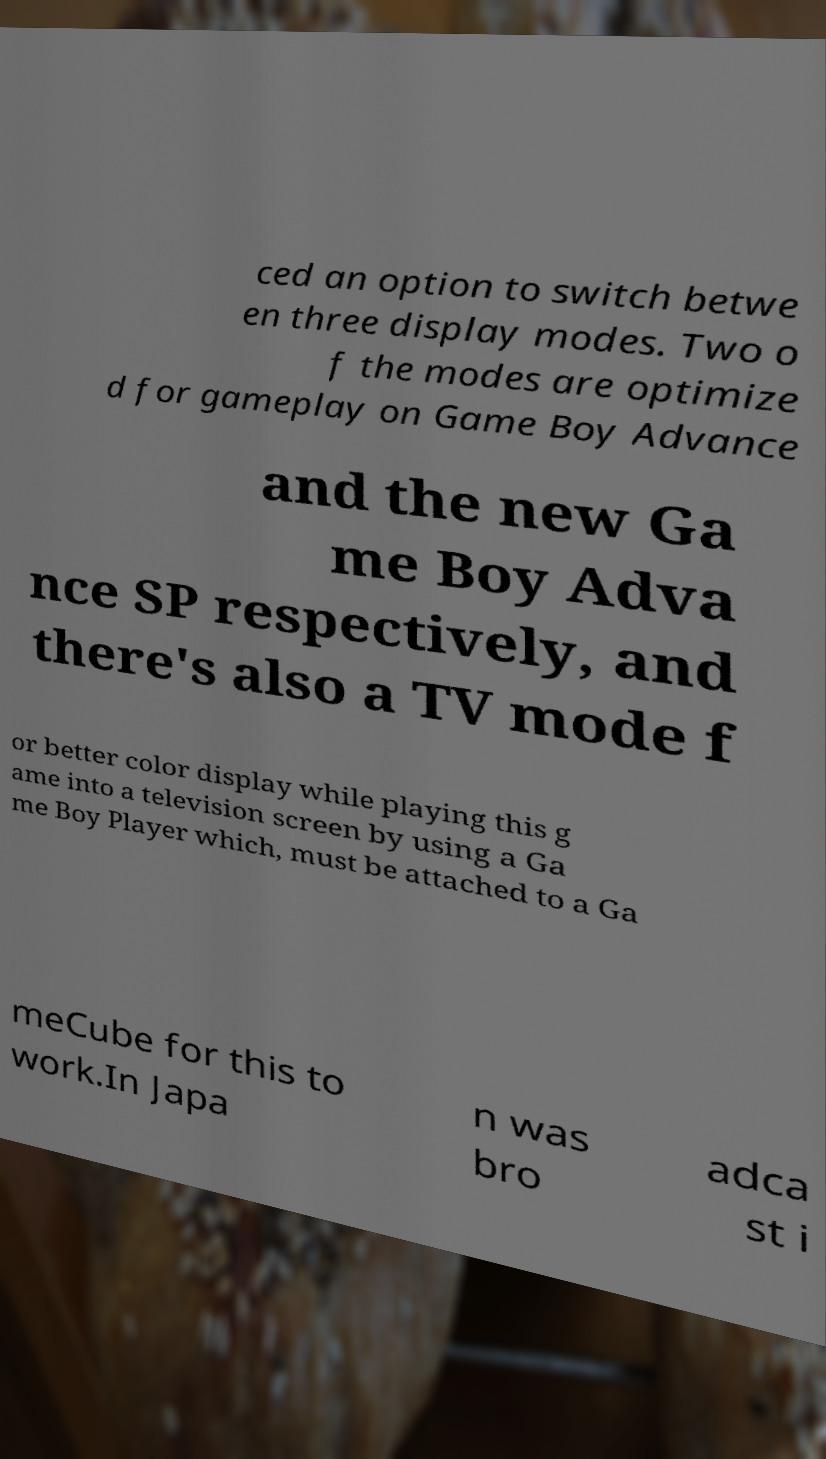What messages or text are displayed in this image? I need them in a readable, typed format. ced an option to switch betwe en three display modes. Two o f the modes are optimize d for gameplay on Game Boy Advance and the new Ga me Boy Adva nce SP respectively, and there's also a TV mode f or better color display while playing this g ame into a television screen by using a Ga me Boy Player which, must be attached to a Ga meCube for this to work.In Japa n was bro adca st i 